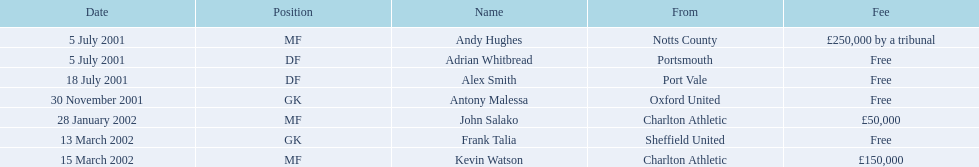What are the names of all the players? Andy Hughes, Adrian Whitbread, Alex Smith, Antony Malessa, John Salako, Frank Talia, Kevin Watson. What fee did andy hughes command? £250,000 by a tribunal. What fee did john salako command? £50,000. Which player had the highest fee, andy hughes or john salako? Andy Hughes. 